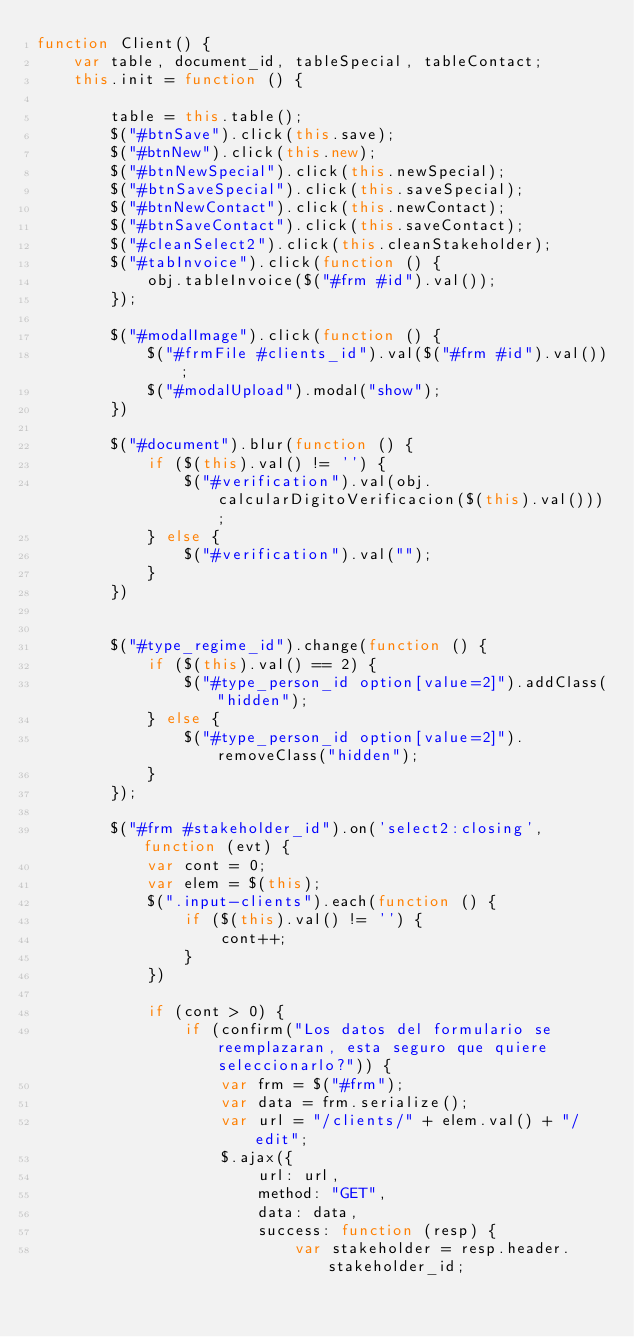Convert code to text. <code><loc_0><loc_0><loc_500><loc_500><_JavaScript_>function Client() {
    var table, document_id, tableSpecial, tableContact;
    this.init = function () {

        table = this.table();
        $("#btnSave").click(this.save);
        $("#btnNew").click(this.new);
        $("#btnNewSpecial").click(this.newSpecial);
        $("#btnSaveSpecial").click(this.saveSpecial);
        $("#btnNewContact").click(this.newContact);
        $("#btnSaveContact").click(this.saveContact);
        $("#cleanSelect2").click(this.cleanStakeholder);
        $("#tabInvoice").click(function () {
            obj.tableInvoice($("#frm #id").val());
        });

        $("#modalImage").click(function () {
            $("#frmFile #clients_id").val($("#frm #id").val());
            $("#modalUpload").modal("show");
        })

        $("#document").blur(function () {
            if ($(this).val() != '') {
                $("#verification").val(obj.calcularDigitoVerificacion($(this).val()));
            } else {
                $("#verification").val("");
            }
        })


        $("#type_regime_id").change(function () {
            if ($(this).val() == 2) {
                $("#type_person_id option[value=2]").addClass("hidden");
            } else {
                $("#type_person_id option[value=2]").removeClass("hidden");
            }
        });

        $("#frm #stakeholder_id").on('select2:closing', function (evt) {
            var cont = 0;
            var elem = $(this);
            $(".input-clients").each(function () {
                if ($(this).val() != '') {
                    cont++;
                }
            })

            if (cont > 0) {
                if (confirm("Los datos del formulario se reemplazaran, esta seguro que quiere seleccionarlo?")) {
                    var frm = $("#frm");
                    var data = frm.serialize();
                    var url = "/clients/" + elem.val() + "/edit";
                    $.ajax({
                        url: url,
                        method: "GET",
                        data: data,
                        success: function (resp) {
                            var stakeholder = resp.header.stakeholder_id;</code> 